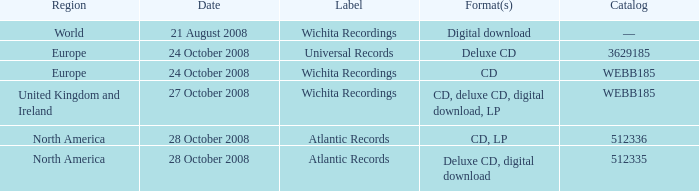Which territory is connected to the catalog value of 512335? North America. 